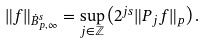<formula> <loc_0><loc_0><loc_500><loc_500>\| f \| _ { \dot { B } ^ { s } _ { p , \infty } } = \sup _ { j \in \mathbb { Z } } \left ( 2 ^ { j s } \| P _ { j } f \| _ { p } \right ) .</formula> 